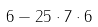Convert formula to latex. <formula><loc_0><loc_0><loc_500><loc_500>6 - 2 5 \cdot 7 \cdot 6</formula> 